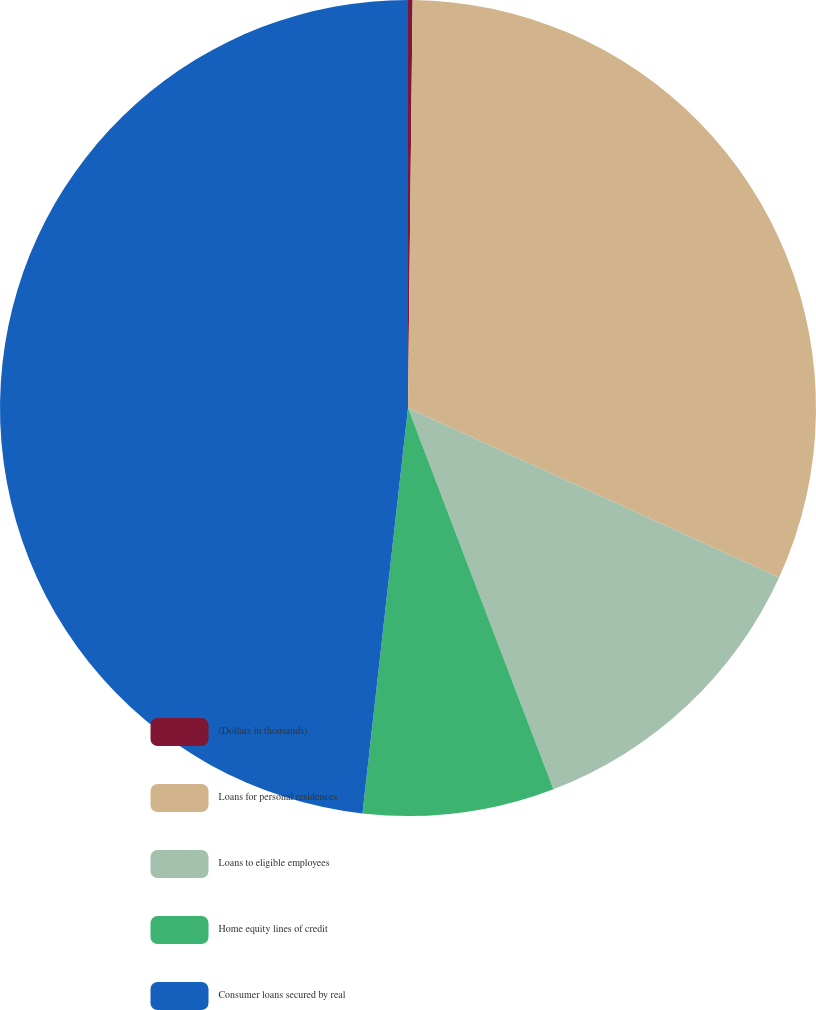Convert chart. <chart><loc_0><loc_0><loc_500><loc_500><pie_chart><fcel>(Dollars in thousands)<fcel>Loans for personal residences<fcel>Loans to eligible employees<fcel>Home equity lines of credit<fcel>Consumer loans secured by real<nl><fcel>0.18%<fcel>31.64%<fcel>12.38%<fcel>7.58%<fcel>48.22%<nl></chart> 